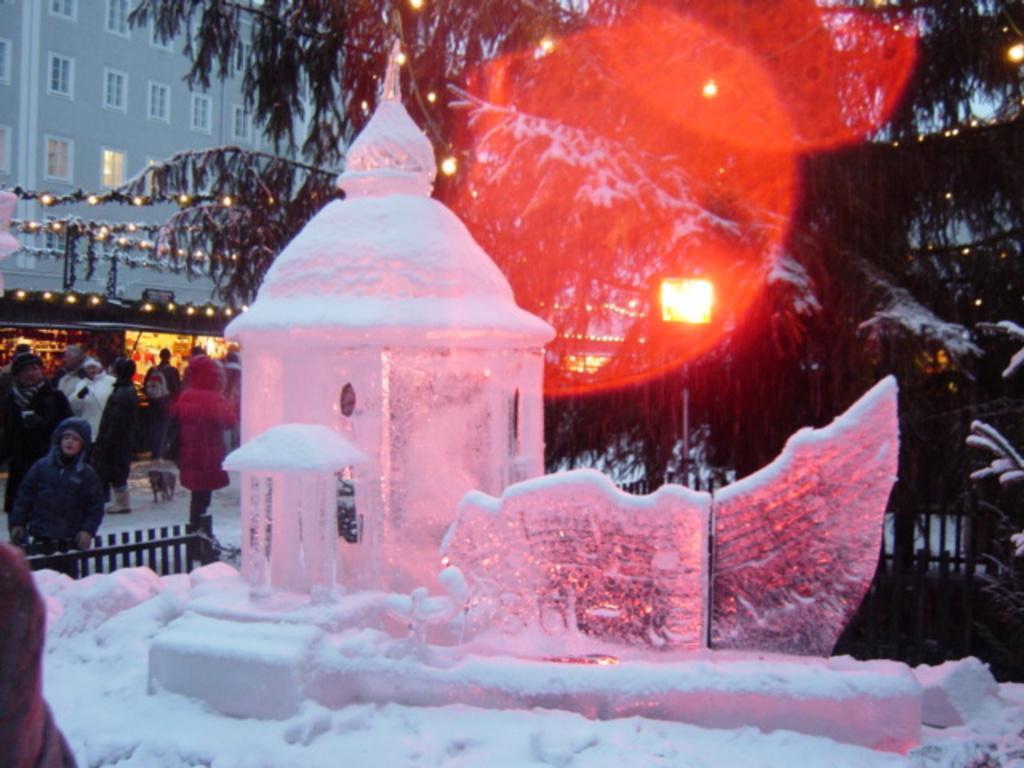Please provide a concise description of this image. In this image there is a ice sculpture of a building , and at the background there is fence , trees, building, stalls, lights, group of people standing on the snow. 